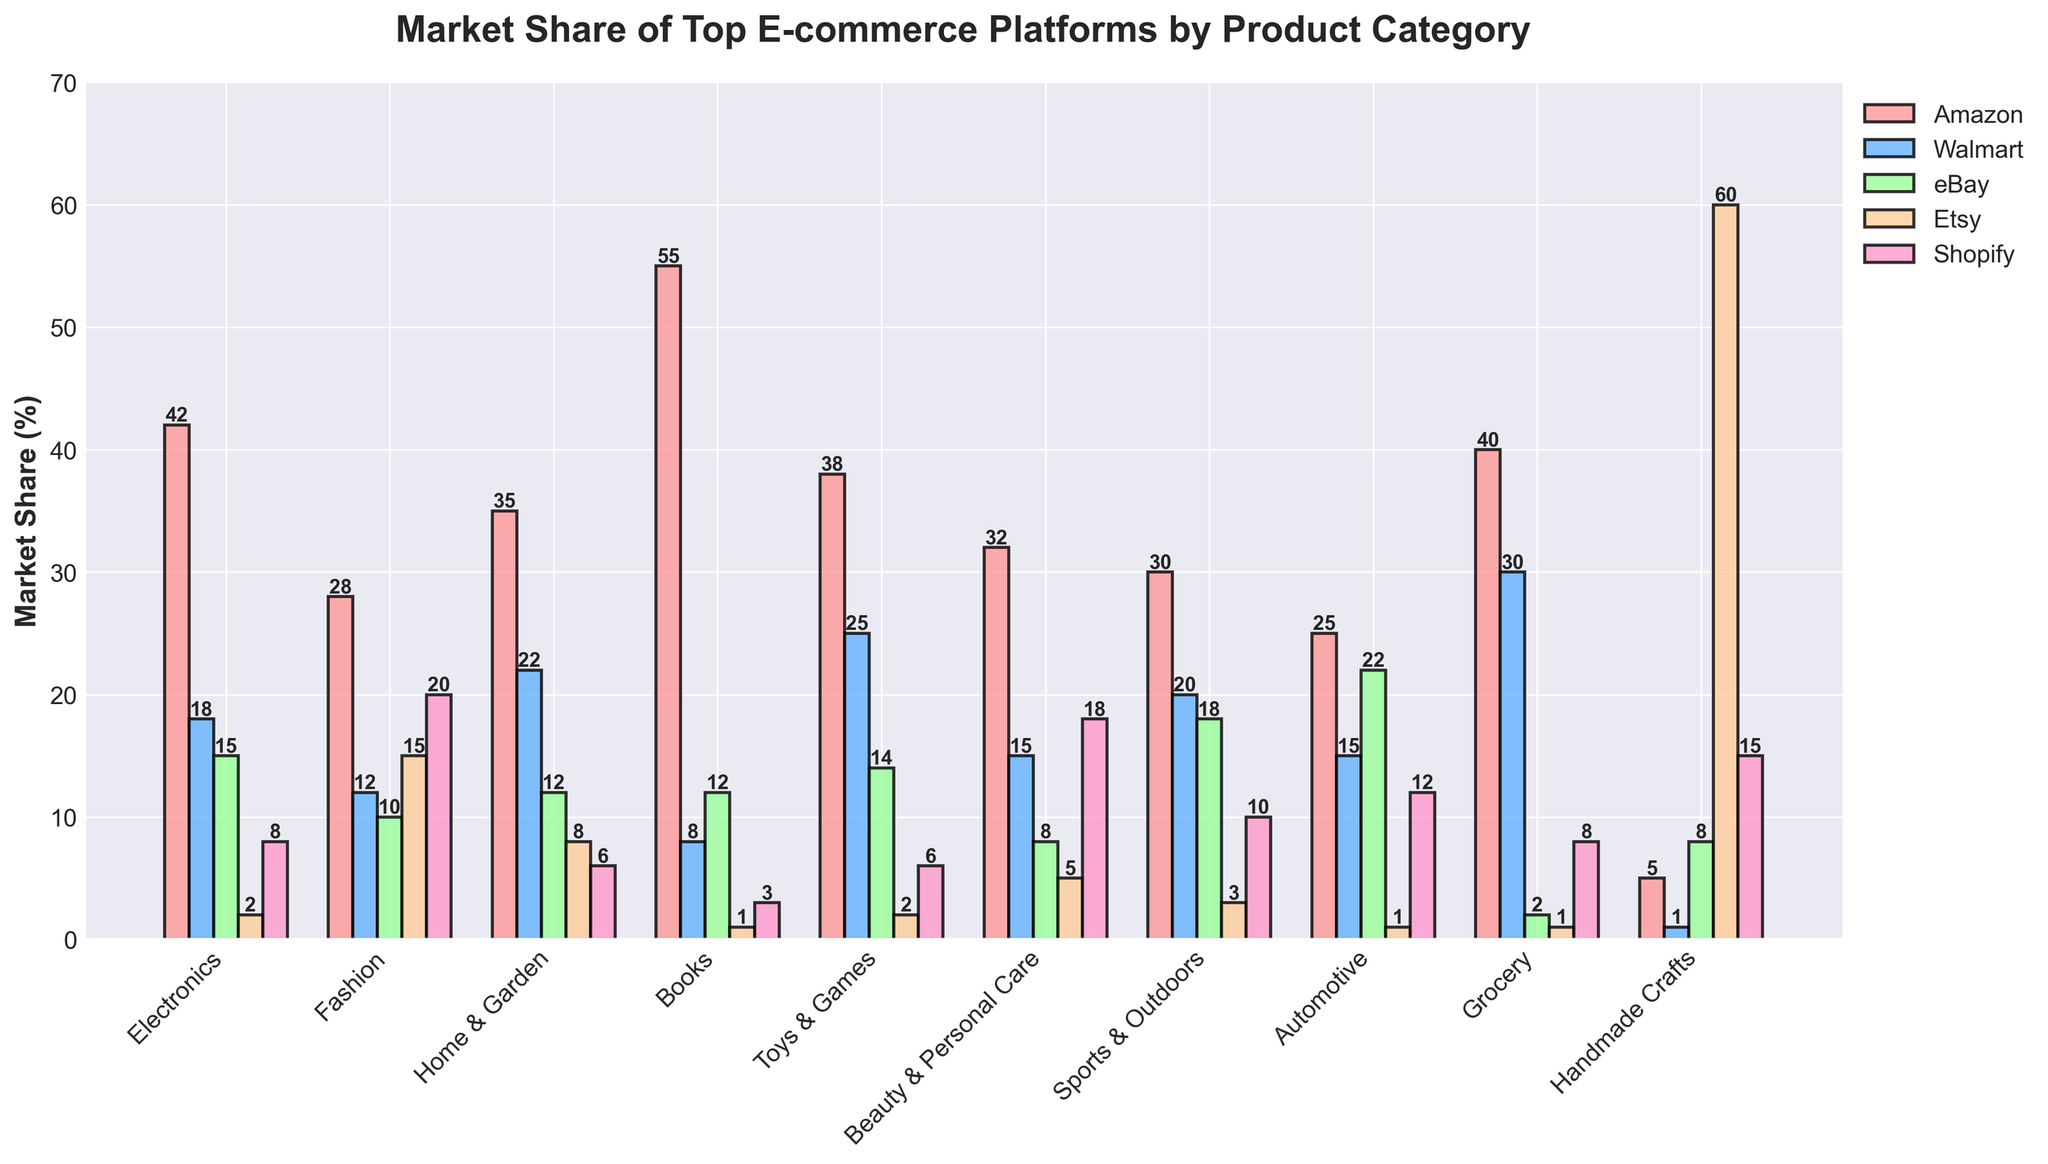What's the market share of Amazon in the Electronics category? Check the height of the bar representing Amazon in the Electronics category; it is at 42.
Answer: 42% Which platform has the highest market share in Handmade Crafts? Compare the heights of the bars for each platform in the Handmade Crafts category. The bar for Etsy is the tallest, at 60.
Answer: Etsy How much more market share does Amazon have in Books compared to Walmart in the same category? Look at the heights of the Amazon and Walmart bars in the Books category. Amazon has 55, and Walmart has 8. Calculate the difference: 55 - 8 = 47.
Answer: 47% Which category does Shopify have the highest market share in? Identify the category where the bar for Shopify is the tallest. Shopify's highest bar is in Fashion at 20.
Answer: Fashion What's the combined market share of Amazon and Walmart in Grocery? Find the values for Amazon and Walmart in Grocery (40 and 30, respectively) and add them: 40 + 30 = 70.
Answer: 70% In which categories does eBay have a market share greater than 15%? Check the heights of the bars for eBay in each category. eBay has more than 15% in Electronics (15), Sports & Outdoors (18), and Automotive (22).
Answer: Electronics, Sports & Outdoors, Automotive Which platform has the smallest market share in beauty & personal care? Look at the heights of the bars for each platform in Beauty & Personal Care. The shortest bar is for eBay at 8.
Answer: eBay What is the difference between the highest and lowest market shares in the Fashion category? Identify the highest and lowest values for the Fashion category. The highest is Shopify (20), and the lowest is eBay (10). Calculate the difference: 20 - 10 = 10.
Answer: 10% Which category has the widest range of market shares among the platforms? Determine the range (difference between maximum and minimum market shares) for each category and compare. Handmade Crafts has a range of 60 - 1 = 59, which is the widest.
Answer: Handmade Crafts What is the average market share of Walmart across all categories? Sum the market shares of Walmart in all categories (18 + 12 + 22 + 8 + 25 + 15 + 20 + 15 + 30 + 1 = 166) and divide by the number of categories (10): 166 / 10 = 16.6.
Answer: 16.6% 